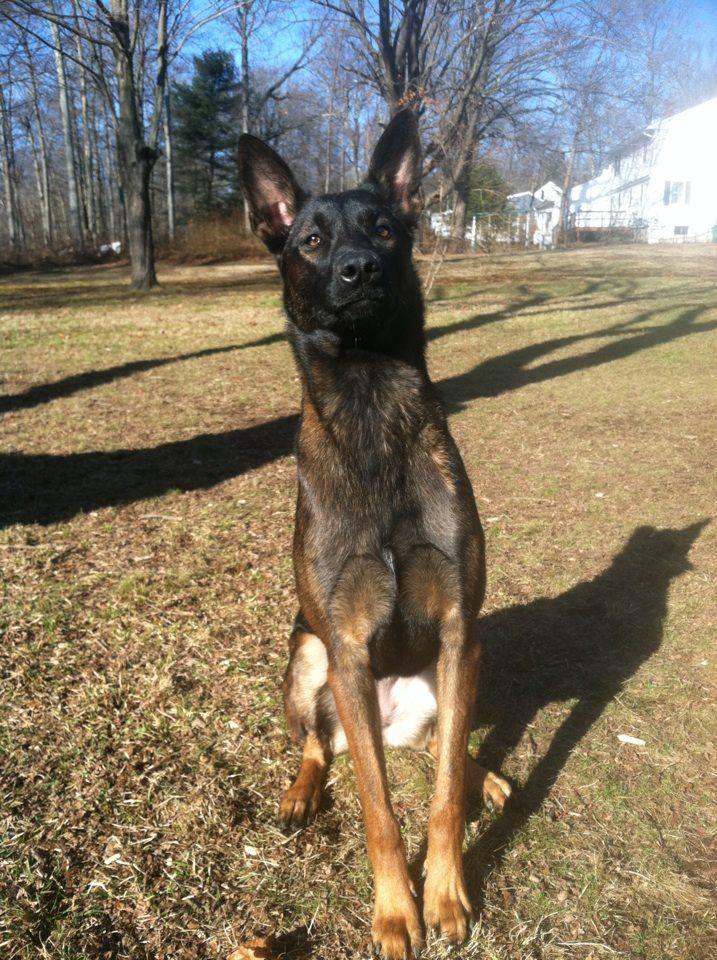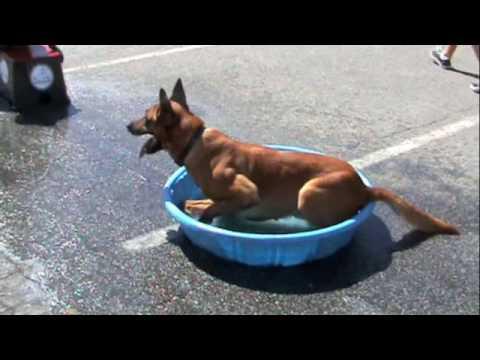The first image is the image on the left, the second image is the image on the right. Analyze the images presented: Is the assertion "At least one person appears in each image." valid? Answer yes or no. No. The first image is the image on the left, the second image is the image on the right. For the images shown, is this caption "There are no less than two humans" true? Answer yes or no. No. 